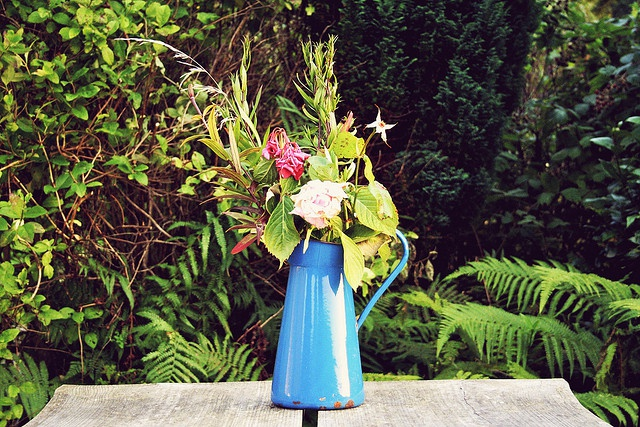Describe the objects in this image and their specific colors. I can see potted plant in brown, black, darkgreen, maroon, and green tones and vase in brown, lightblue, and ivory tones in this image. 